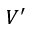Convert formula to latex. <formula><loc_0><loc_0><loc_500><loc_500>V ^ { \prime }</formula> 